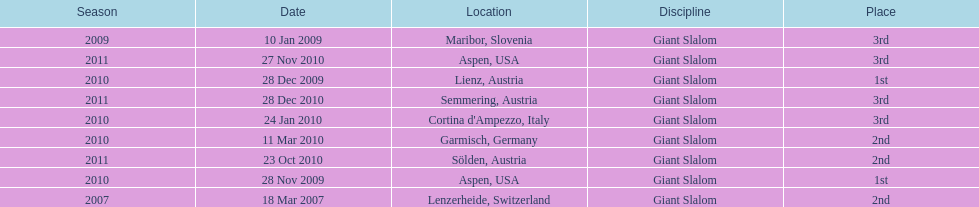The final race finishing place was not 1st but what other place? 3rd. 